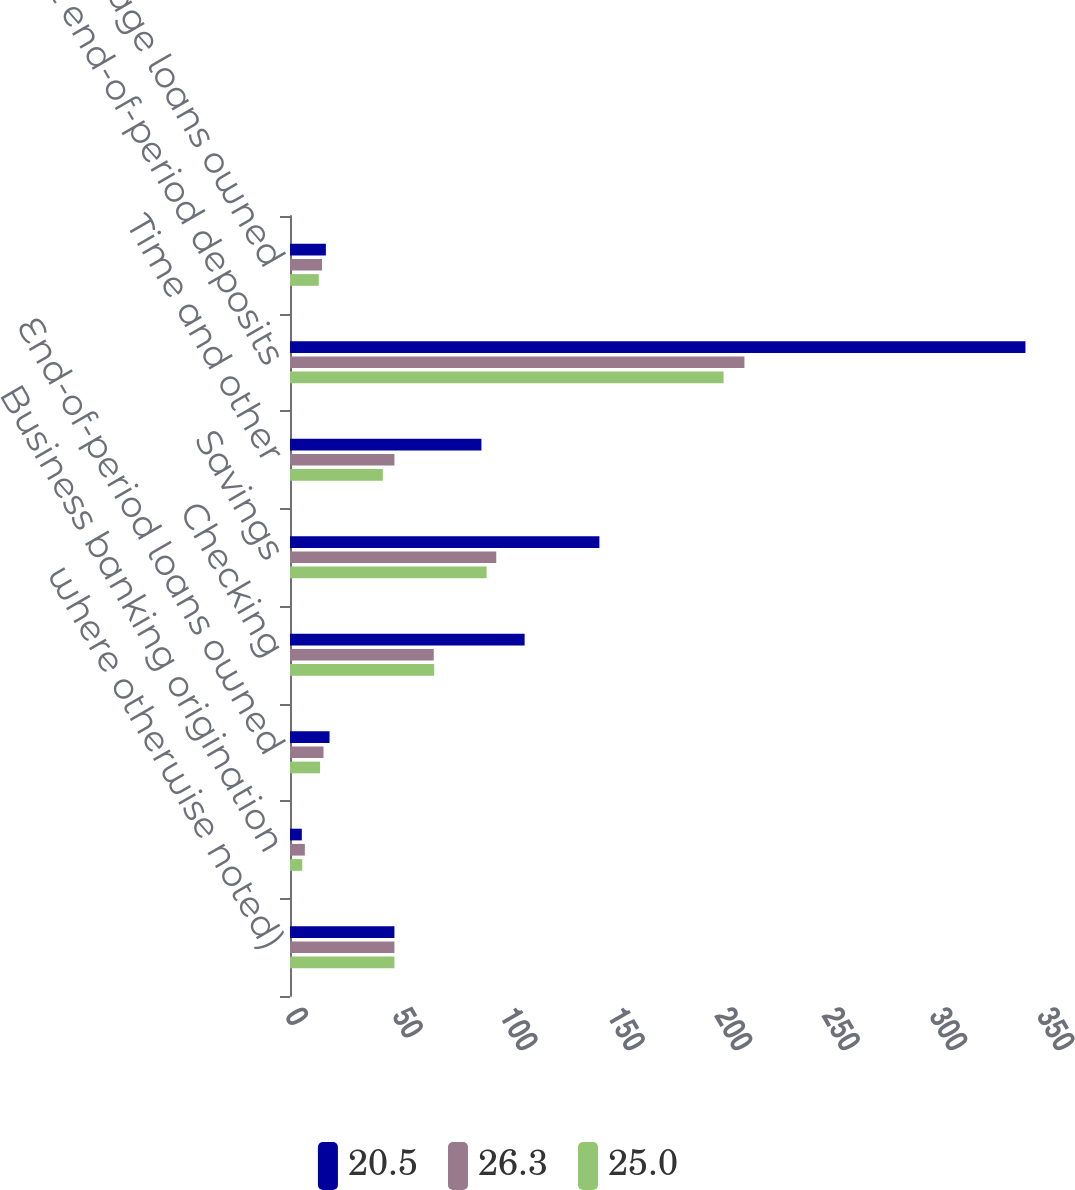Convert chart to OTSL. <chart><loc_0><loc_0><loc_500><loc_500><stacked_bar_chart><ecel><fcel>where otherwise noted)<fcel>Business banking origination<fcel>End-of-period loans owned<fcel>Checking<fcel>Savings<fcel>Time and other<fcel>Total end-of-period deposits<fcel>Average loans owned<nl><fcel>20.5<fcel>48.6<fcel>5.5<fcel>18.4<fcel>109.2<fcel>144<fcel>89.1<fcel>342.3<fcel>16.7<nl><fcel>26.3<fcel>48.6<fcel>6.9<fcel>15.6<fcel>66.9<fcel>96<fcel>48.6<fcel>211.5<fcel>14.9<nl><fcel>25<fcel>48.6<fcel>5.7<fcel>14<fcel>67.1<fcel>91.5<fcel>43.2<fcel>201.8<fcel>13.4<nl></chart> 